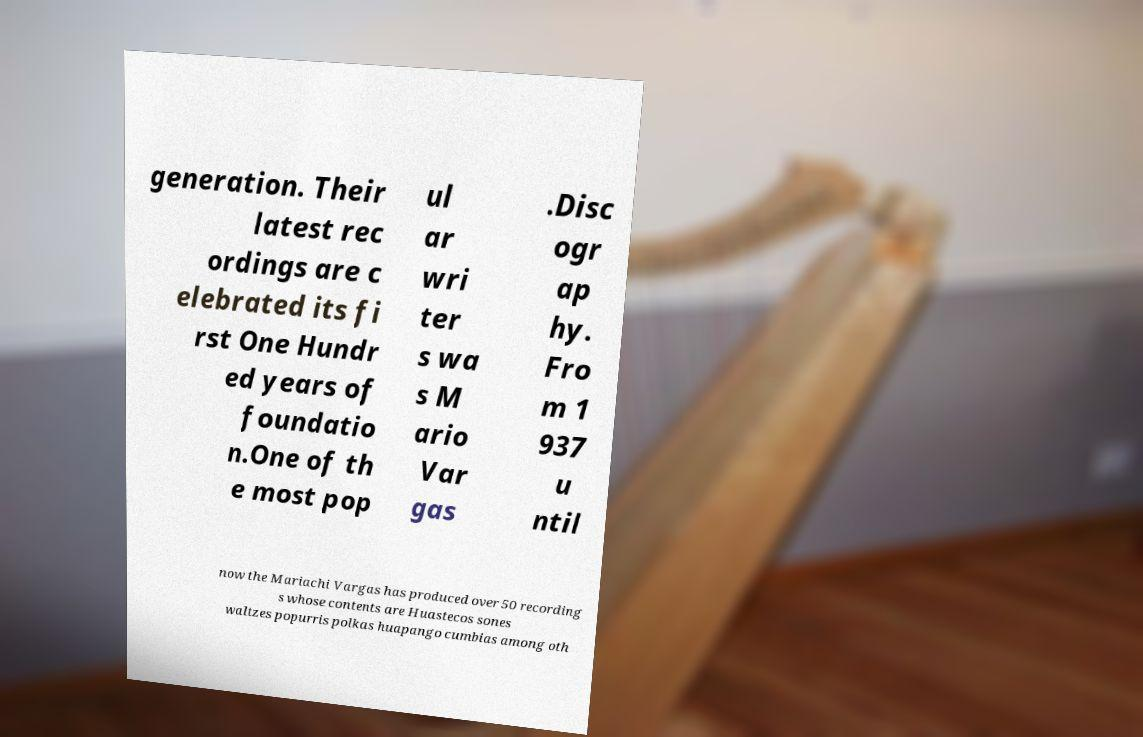What messages or text are displayed in this image? I need them in a readable, typed format. generation. Their latest rec ordings are c elebrated its fi rst One Hundr ed years of foundatio n.One of th e most pop ul ar wri ter s wa s M ario Var gas .Disc ogr ap hy. Fro m 1 937 u ntil now the Mariachi Vargas has produced over 50 recording s whose contents are Huastecos sones waltzes popurris polkas huapango cumbias among oth 